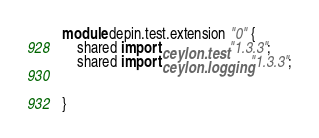Convert code to text. <code><loc_0><loc_0><loc_500><loc_500><_Ceylon_>module depin.test.extension "0" {
	shared import ceylon.test "1.3.3";
	shared import ceylon.logging "1.3.3";
	
	
}
</code> 